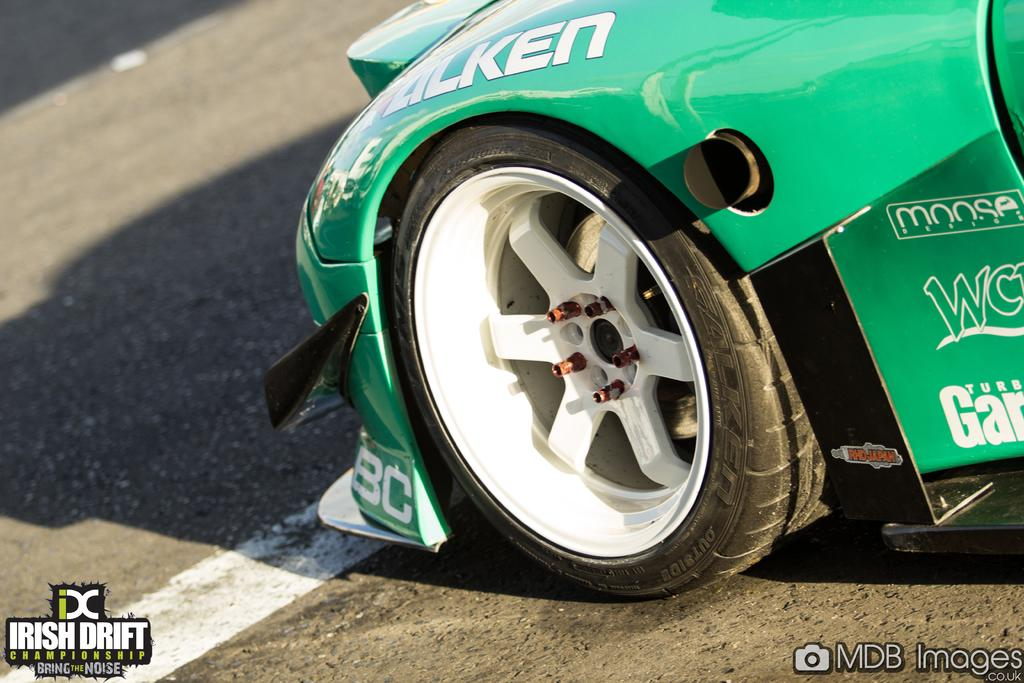What color is the car in the image? The car in the image is green. Where is the car located in the image? The car is on the road. Where is the baby in the image? There is no baby present in the image; it only features a green color car on the road. What type of jar can be seen on the car's dashboard? There is no jar visible on the car's dashboard in the image. 